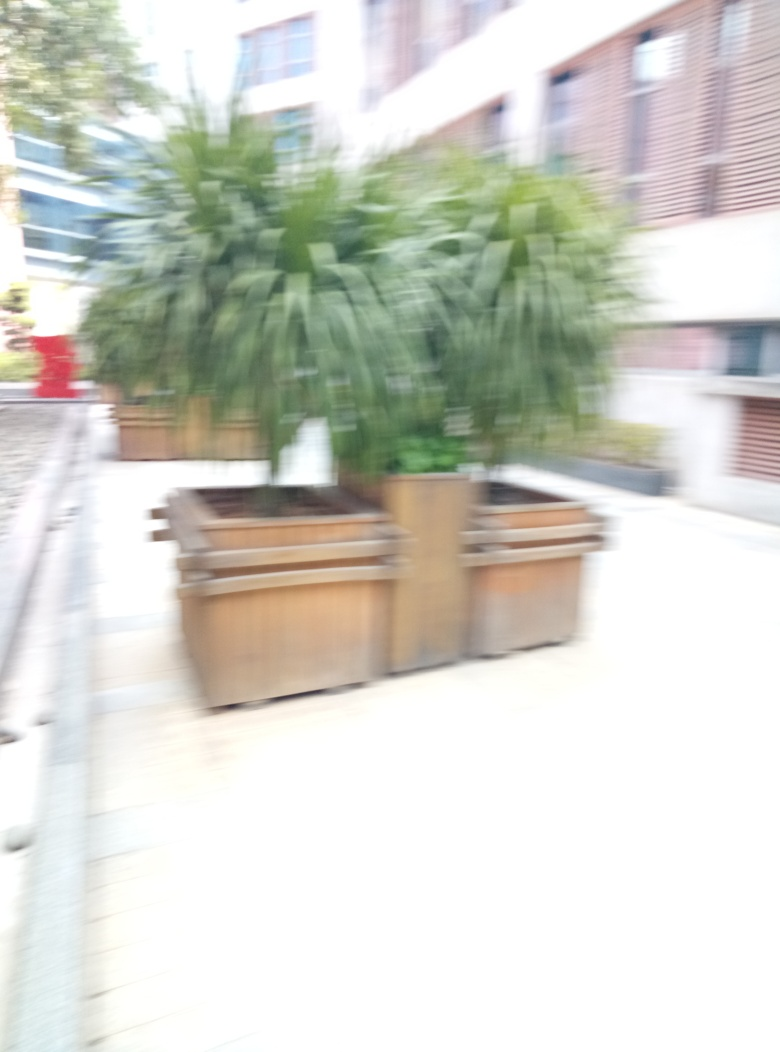What time of day does this photo seem to have been taken? Based on the lighting and shadows, it's difficult to determine the exact time of day the photo was taken due to the blurring. However, the presence of natural light and a lack of strong shadows could suggest it was an overcast day or the photo was taken in a shaded area. 